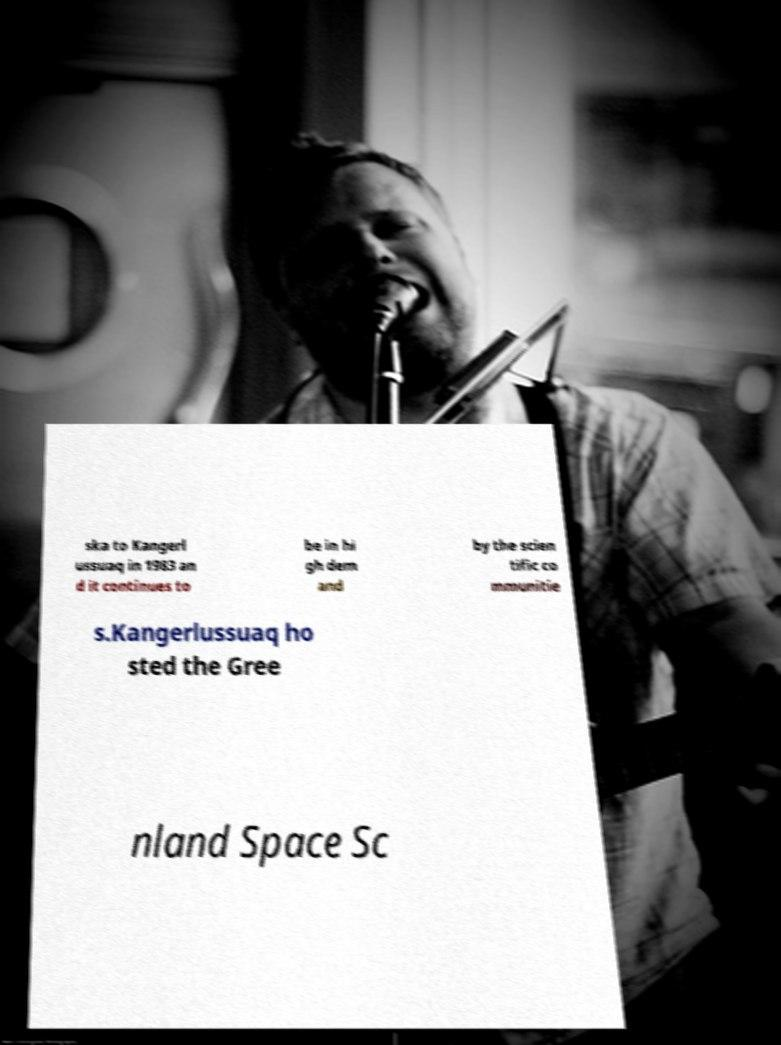For documentation purposes, I need the text within this image transcribed. Could you provide that? ska to Kangerl ussuaq in 1983 an d it continues to be in hi gh dem and by the scien tific co mmunitie s.Kangerlussuaq ho sted the Gree nland Space Sc 